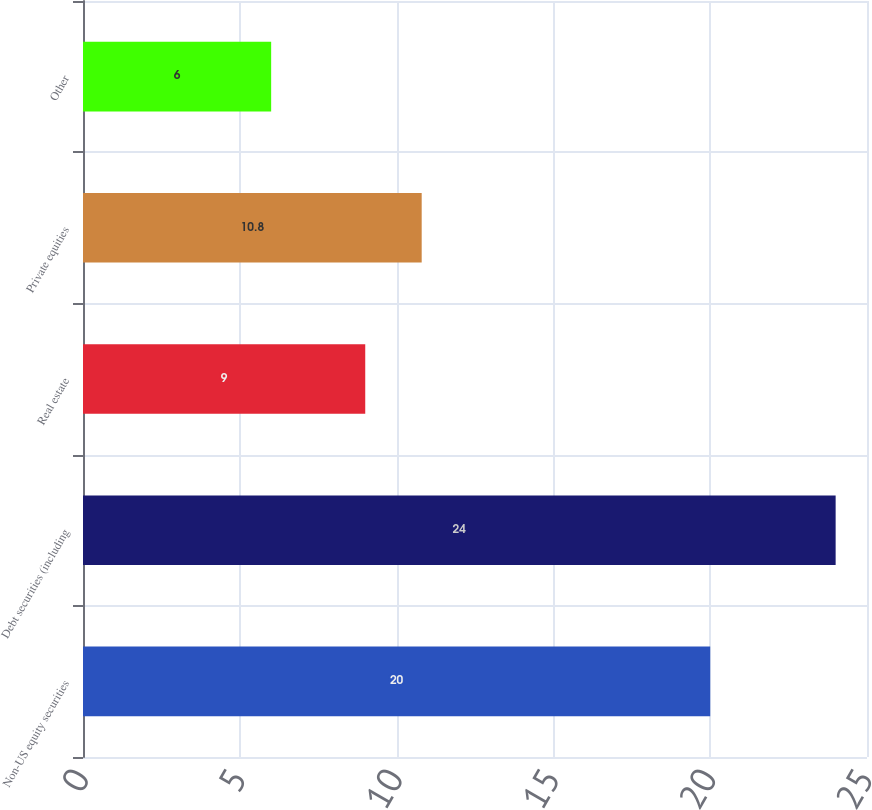<chart> <loc_0><loc_0><loc_500><loc_500><bar_chart><fcel>Non-US equity securities<fcel>Debt securities (including<fcel>Real estate<fcel>Private equities<fcel>Other<nl><fcel>20<fcel>24<fcel>9<fcel>10.8<fcel>6<nl></chart> 